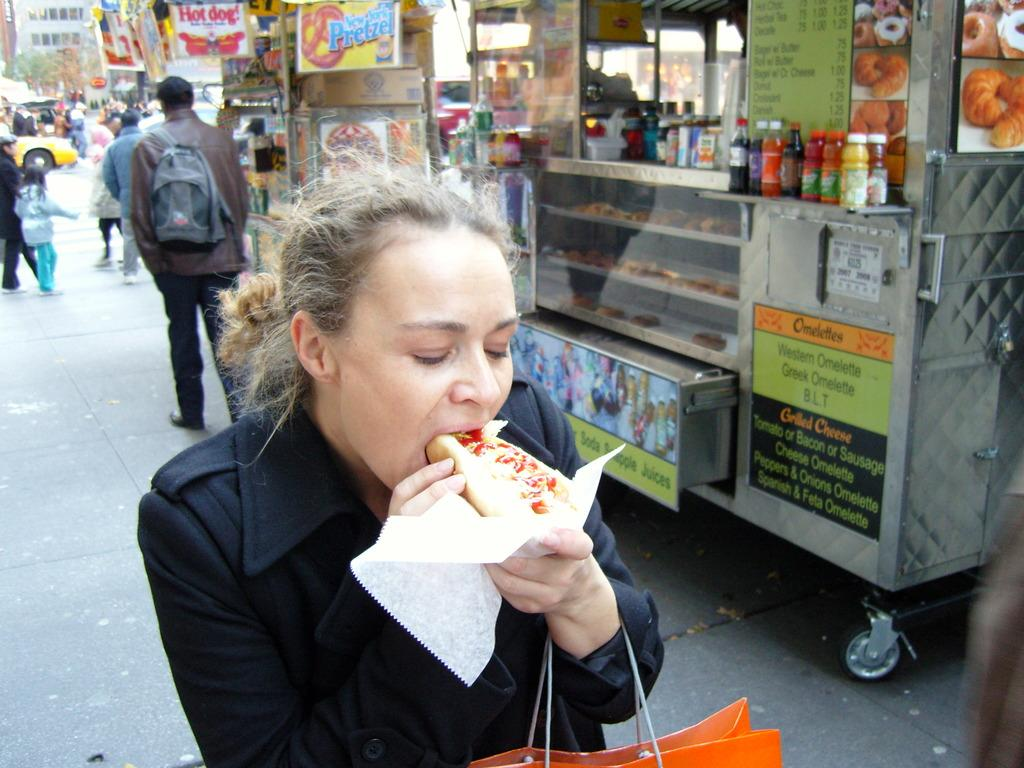Provide a one-sentence caption for the provided image. A woman enjoys a hot dog in front of a food cart offering grilled cheese, omelettes and other items. 